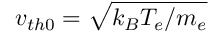<formula> <loc_0><loc_0><loc_500><loc_500>v _ { t h 0 } = \sqrt { k _ { B } T _ { e } / m _ { e } }</formula> 